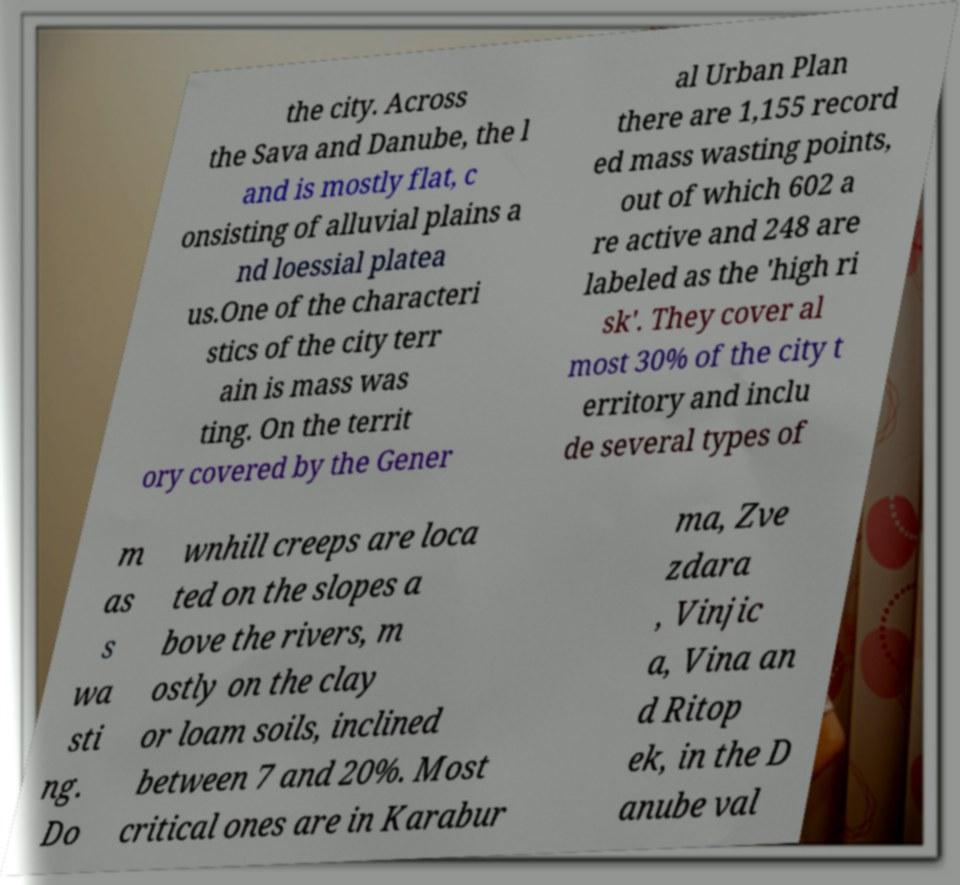Could you assist in decoding the text presented in this image and type it out clearly? the city. Across the Sava and Danube, the l and is mostly flat, c onsisting of alluvial plains a nd loessial platea us.One of the characteri stics of the city terr ain is mass was ting. On the territ ory covered by the Gener al Urban Plan there are 1,155 record ed mass wasting points, out of which 602 a re active and 248 are labeled as the 'high ri sk'. They cover al most 30% of the city t erritory and inclu de several types of m as s wa sti ng. Do wnhill creeps are loca ted on the slopes a bove the rivers, m ostly on the clay or loam soils, inclined between 7 and 20%. Most critical ones are in Karabur ma, Zve zdara , Vinjic a, Vina an d Ritop ek, in the D anube val 